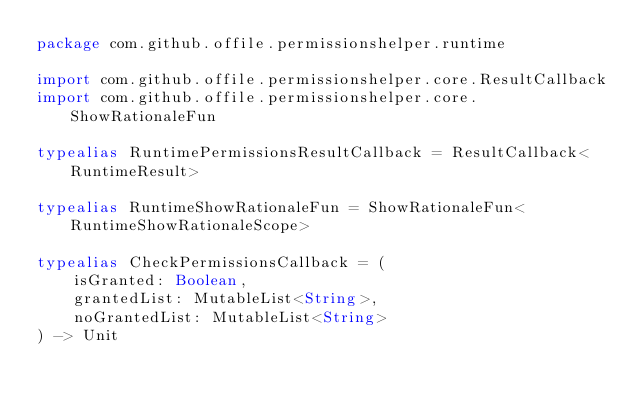Convert code to text. <code><loc_0><loc_0><loc_500><loc_500><_Kotlin_>package com.github.offile.permissionshelper.runtime

import com.github.offile.permissionshelper.core.ResultCallback
import com.github.offile.permissionshelper.core.ShowRationaleFun

typealias RuntimePermissionsResultCallback = ResultCallback<RuntimeResult>

typealias RuntimeShowRationaleFun = ShowRationaleFun<RuntimeShowRationaleScope>

typealias CheckPermissionsCallback = (
    isGranted: Boolean,
    grantedList: MutableList<String>,
    noGrantedList: MutableList<String>
) -> Unit</code> 